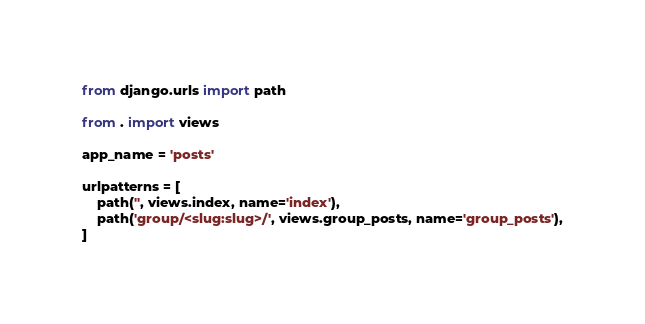<code> <loc_0><loc_0><loc_500><loc_500><_Python_>from django.urls import path

from . import views

app_name = 'posts'

urlpatterns = [
    path('', views.index, name='index'),
    path('group/<slug:slug>/', views.group_posts, name='group_posts'),
] 
</code> 